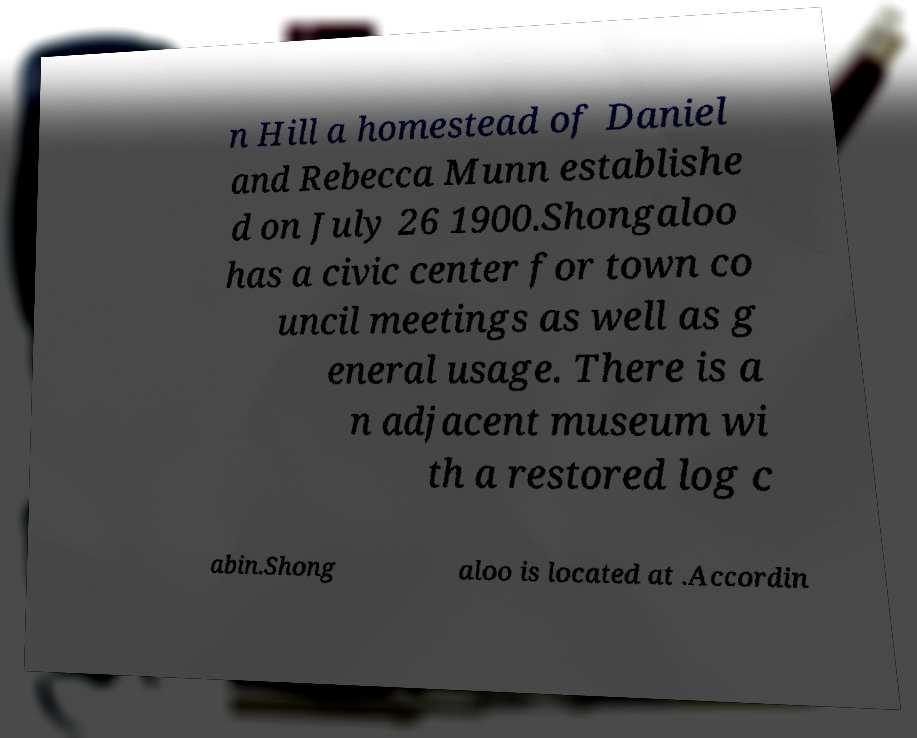Please read and relay the text visible in this image. What does it say? n Hill a homestead of Daniel and Rebecca Munn establishe d on July 26 1900.Shongaloo has a civic center for town co uncil meetings as well as g eneral usage. There is a n adjacent museum wi th a restored log c abin.Shong aloo is located at .Accordin 